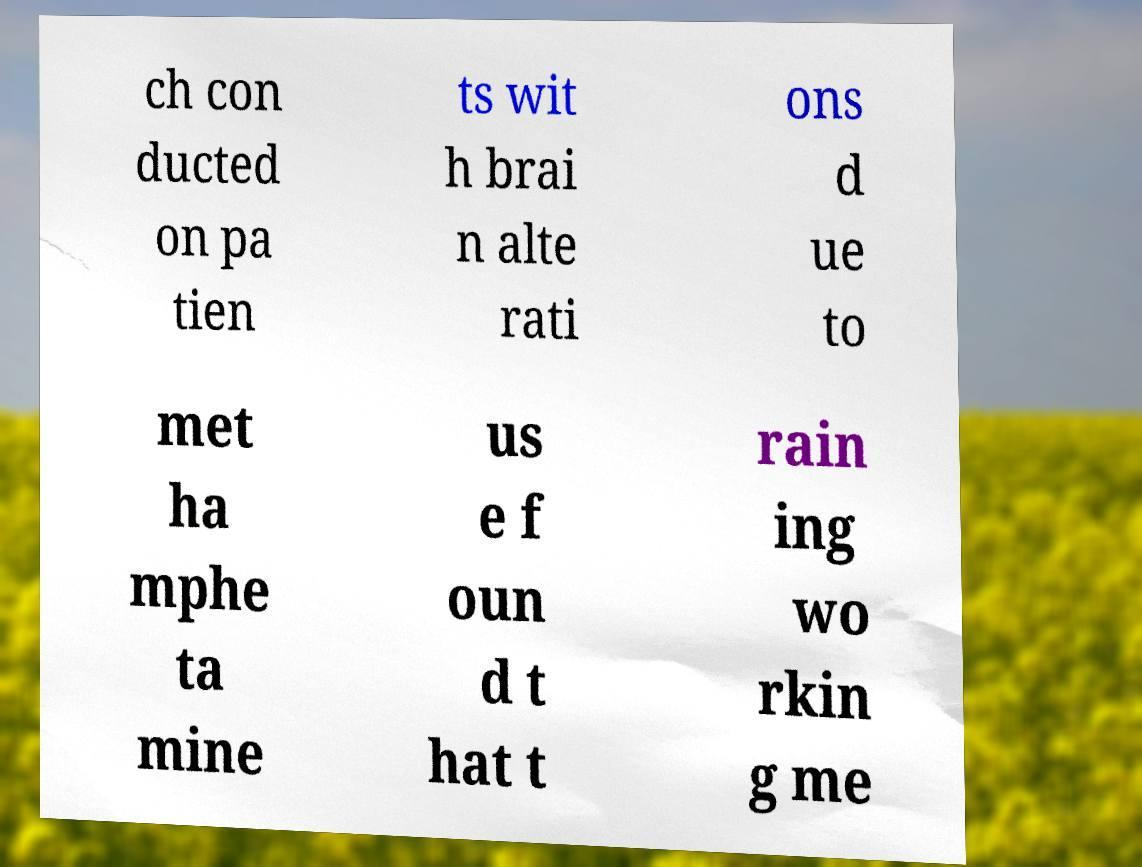Could you assist in decoding the text presented in this image and type it out clearly? ch con ducted on pa tien ts wit h brai n alte rati ons d ue to met ha mphe ta mine us e f oun d t hat t rain ing wo rkin g me 